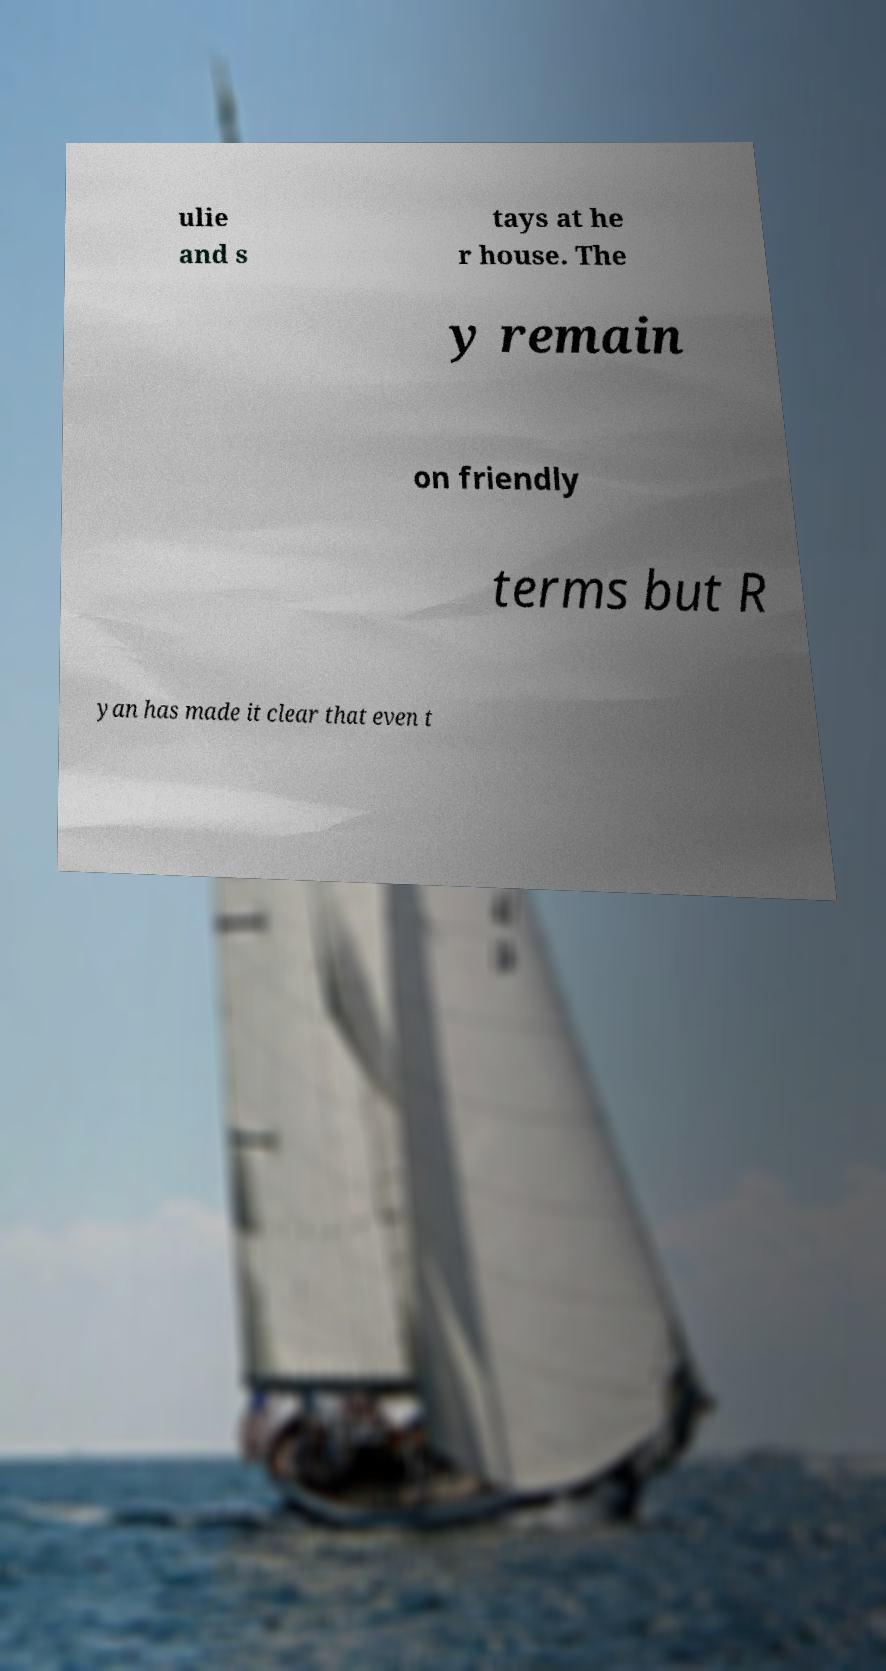Could you assist in decoding the text presented in this image and type it out clearly? ulie and s tays at he r house. The y remain on friendly terms but R yan has made it clear that even t 